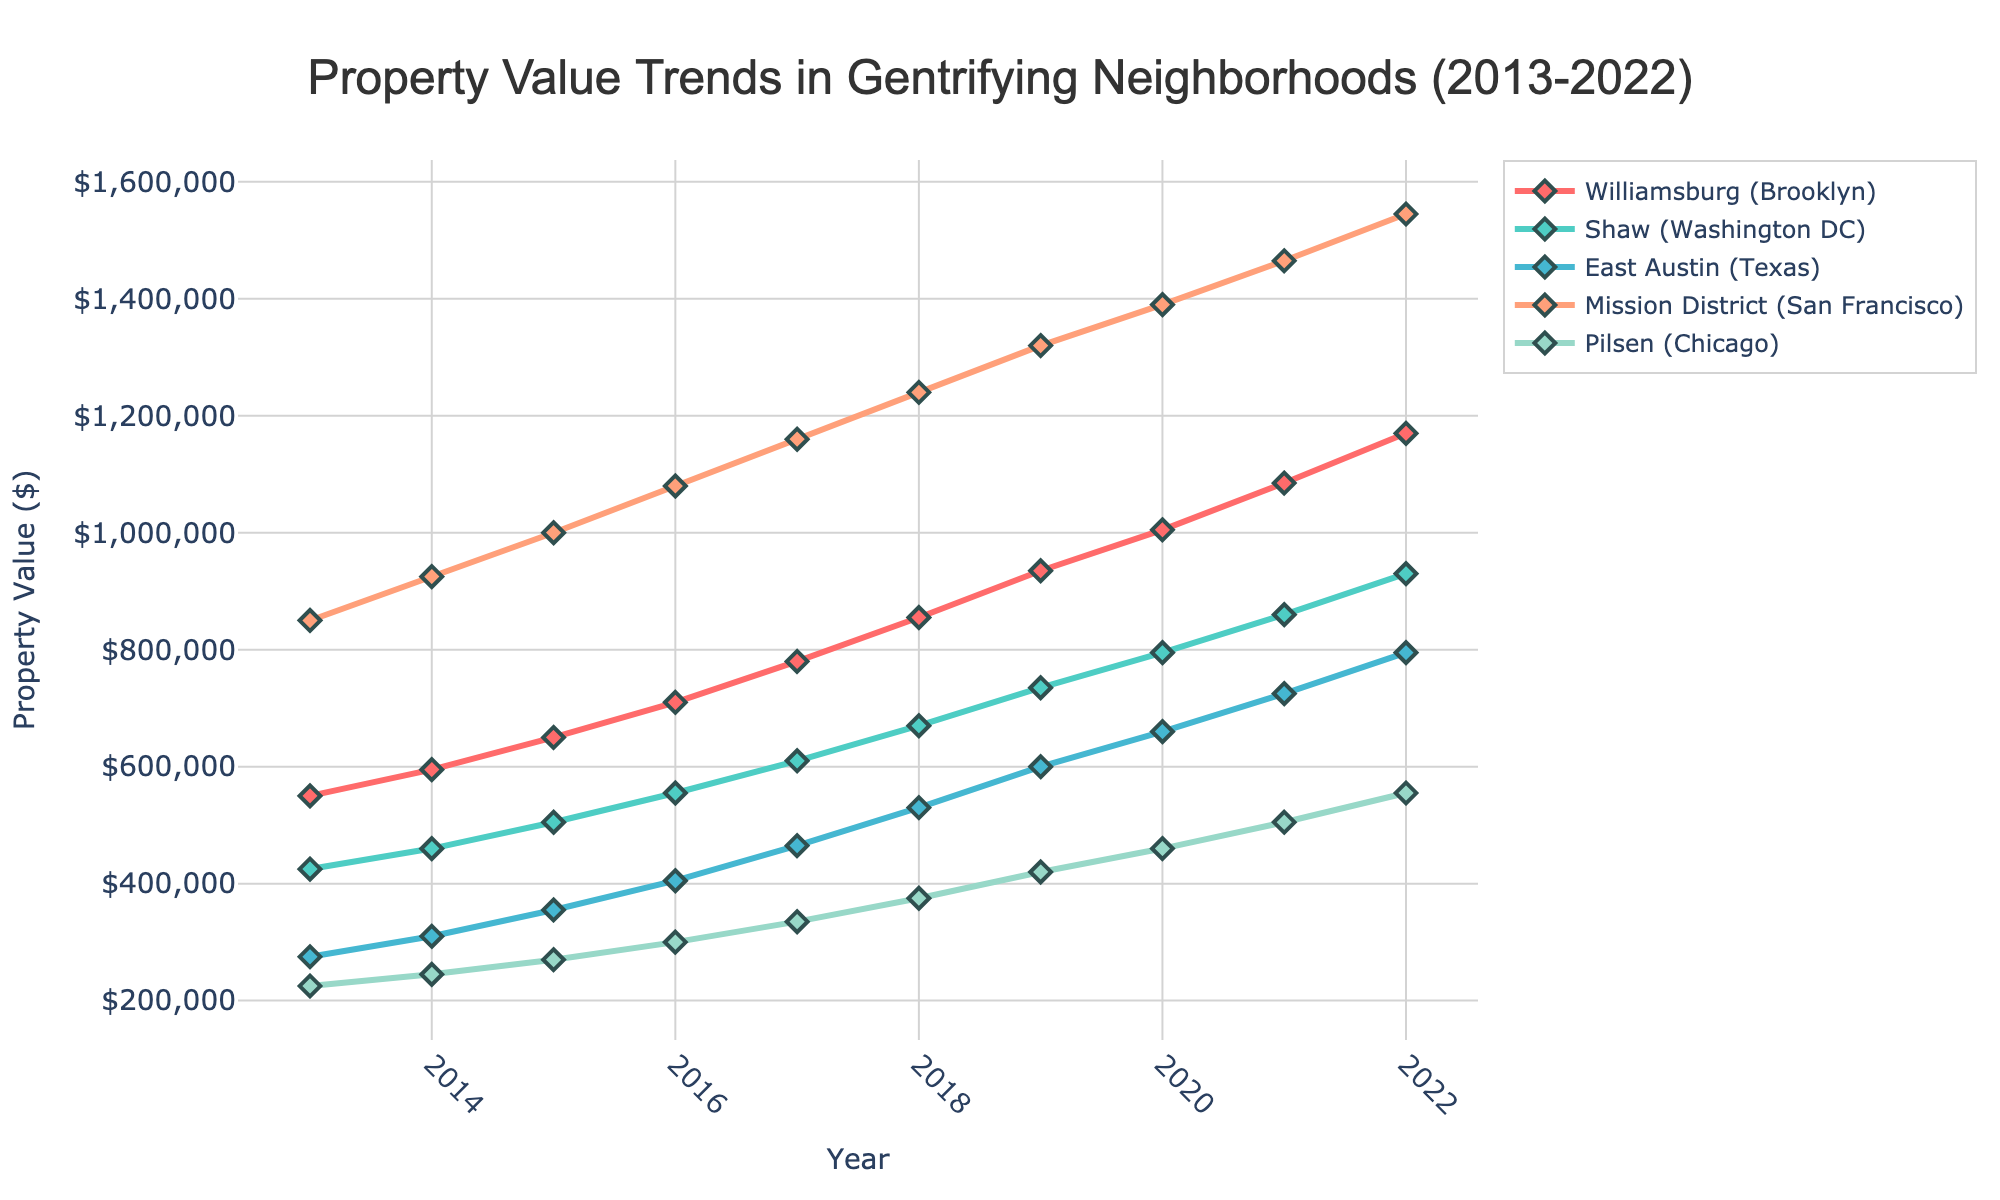What is the average property value in Williamsburg (Brooklyn) over the decade (2013-2022)? Sum the property values from 2013 to 2022 and divide by the number of years: (550000 + 595000 + 650000 + 710000 + 780000 + 855000 + 935000 + 1005000 + 1085000 + 1170000) / 10
Answer: 853000 Which neighborhood had the highest property value in 2022? Look at the property values across all neighborhoods for the year 2022 and identify the highest value.
Answer: Mission District (San Francisco) How much did the property value increase in Shaw (Washington DC) from 2013 to 2022? Subtract the property value in 2013 from the property value in 2022: 930000 - 425000
Answer: 505000 Between 2017 and 2019, which neighborhood saw the largest increase in property value? Calculate the difference in property values between 2017 and 2019 for each neighborhood and compare. The increases are: 
- Williamsburg: 935000 - 780000 = 155000,
- Shaw: 735000 - 610000 = 125000,
- East Austin: 600000 - 465000 = 135000,
- Mission District: 1320000 - 1160000 = 160000,
- Pilsen: 420000 - 335000 = 85000.
Answer: Mission District Which neighborhood had more consistent property value growth over the decade? Observe the line trends for each neighborhood from 2013 to 2022. Consistency is reflected by smooth, gradual increases without significant volatility.
Answer: Shaw (Washington DC) In what year did East Austin (Texas) surpass Pilsen (Chicago) in property value? Compare the property values for East Austin and Pilsen each year until East Austin's value is higher.
Answer: 2016 Compare the property values of Williamsburg (Brooklyn) and Mission District (San Francisco) in 2018. Which is higher and by how much? Subtract the property value of Williamsburg in 2018 from that of Mission District in 2018: 1240000 - 855000
Answer: Mission District, 385000 What was the aggregate property value of all neighborhoods in 2015? Sum the property values for all neighborhoods in the year 2015: 650000 + 505000 + 355000 + 1000000 + 270000
Answer: 3175000 Which neighborhood showed the fastest growth rate in property value during the decade? Determine the growth rate for each neighborhood by calculating the percentage increase from 2013 to 2022. 
- Williamsburg: ((1170000 - 550000) / 550000) * 100 = 112.73%
- Shaw: ((930000 - 425000) / 425000) * 100 = 118.82%
- East Austin: ((795000 - 275000) / 275000) * 100 = 189.09%
- Mission District: ((1545000 - 850000) / 850000) * 100 = 81.76%
- Pilsen: ((555000 - 225000) / 225000) * 100 = 146.67%
Answer: East Austin (Texas) 